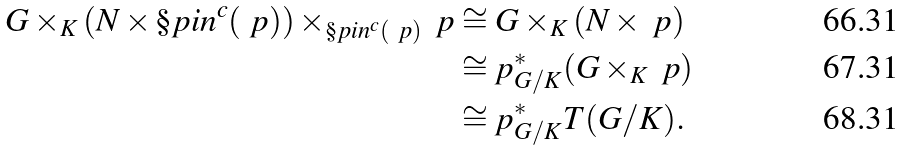Convert formula to latex. <formula><loc_0><loc_0><loc_500><loc_500>G \times _ { K } ( N \times \S p i n ^ { c } ( \ p ) ) \times _ { \S p i n ^ { c } ( \ p ) } \ p & \cong G \times _ { K } ( N \times \ p ) \\ & \cong p _ { G / K } ^ { * } ( G \times _ { K } \ p ) \\ & \cong p _ { G / K } ^ { * } T ( G / K ) .</formula> 